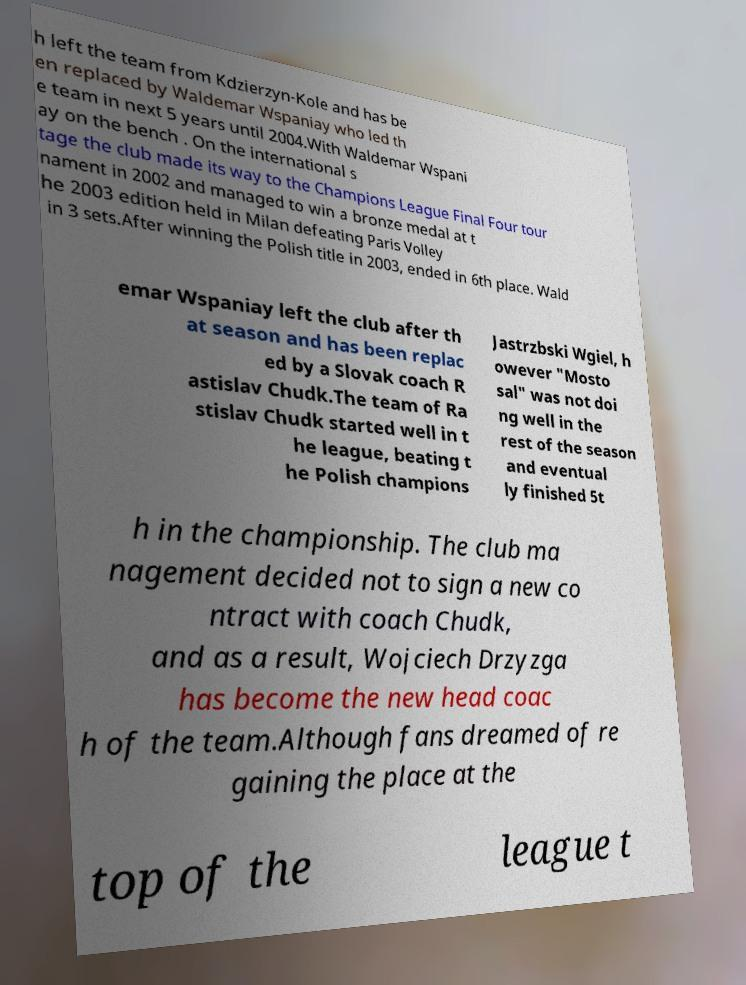Could you extract and type out the text from this image? h left the team from Kdzierzyn-Kole and has be en replaced by Waldemar Wspaniay who led th e team in next 5 years until 2004.With Waldemar Wspani ay on the bench . On the international s tage the club made its way to the Champions League Final Four tour nament in 2002 and managed to win a bronze medal at t he 2003 edition held in Milan defeating Paris Volley in 3 sets.After winning the Polish title in 2003, ended in 6th place. Wald emar Wspaniay left the club after th at season and has been replac ed by a Slovak coach R astislav Chudk.The team of Ra stislav Chudk started well in t he league, beating t he Polish champions Jastrzbski Wgiel, h owever "Mosto sal" was not doi ng well in the rest of the season and eventual ly finished 5t h in the championship. The club ma nagement decided not to sign a new co ntract with coach Chudk, and as a result, Wojciech Drzyzga has become the new head coac h of the team.Although fans dreamed of re gaining the place at the top of the league t 